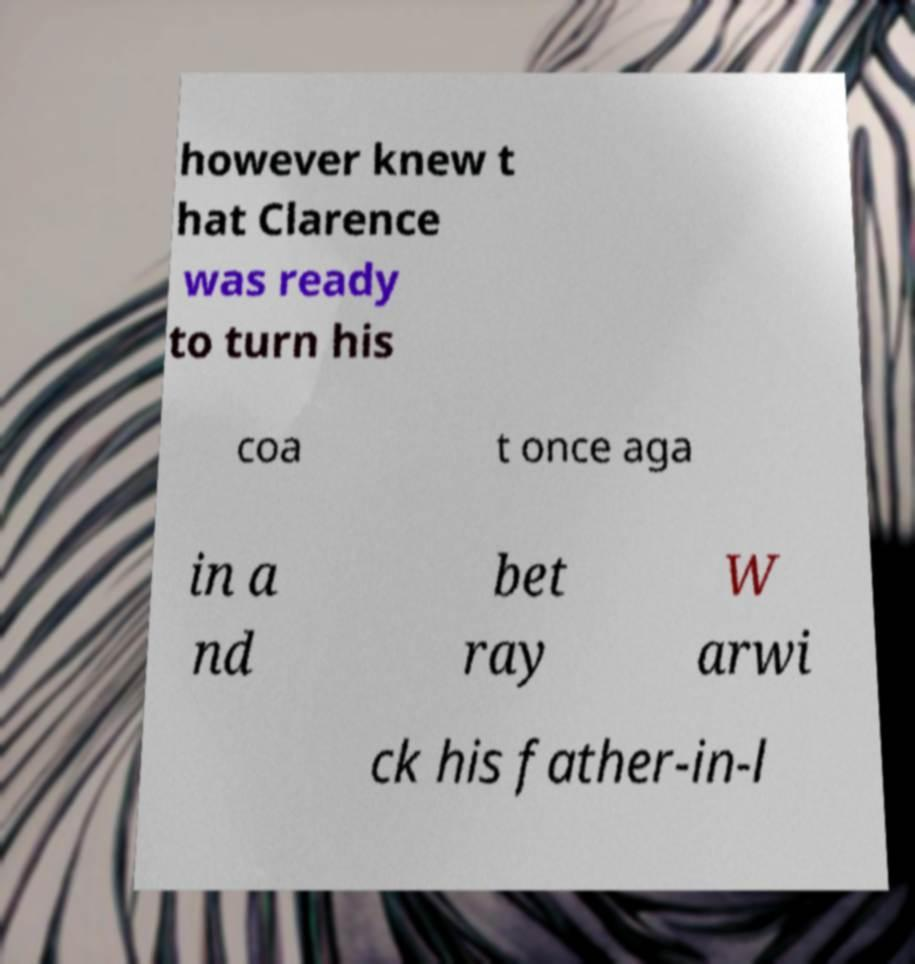There's text embedded in this image that I need extracted. Can you transcribe it verbatim? however knew t hat Clarence was ready to turn his coa t once aga in a nd bet ray W arwi ck his father-in-l 